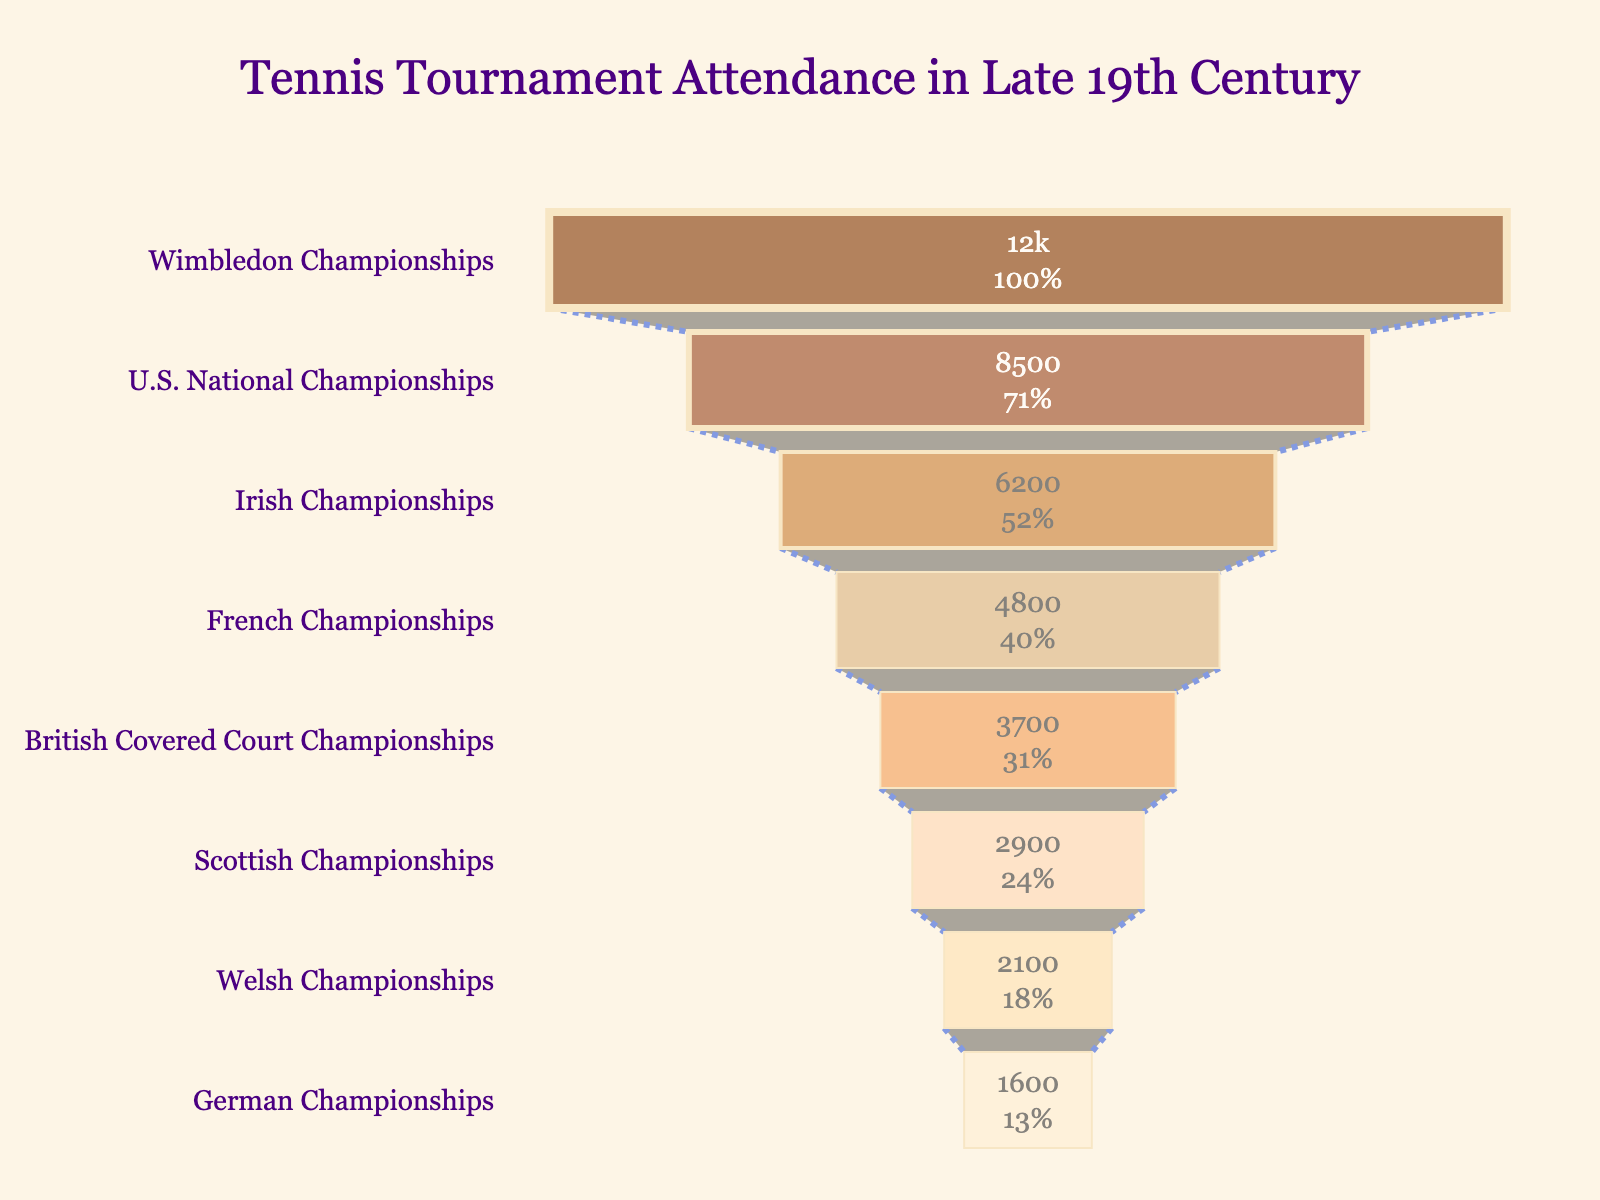What's the title of the chart? The title of the chart is clearly displayed at the top. It reads "Tennis Tournament Attendance in Late 19th Century."
Answer: Tennis Tournament Attendance in Late 19th Century How many tournaments are displayed in the chart? The chart shows multiple data points, each representing a tournament. Counting them, we see there are eight tournaments in total.
Answer: Eight Which tournament had the highest attendance? The highest value on the funnel chart corresponds to the top segment. The tournament at this level is the "Wimbledon Championships" with 12,000 attendance.
Answer: Wimbledon Championships What is the attendance figure for the U.S. National Championships? The funnel chart lists attendance figures alongside tournament names. The U.S. National Championships has an attendance of 8,500.
Answer: 8,500 Compare the attendance of the French Championships to the German Championships. The attendance figure for the French Championships is 4,800, while for the German Championships it is 1,600. The French Championships has a higher attendance.
Answer: French Championships has higher attendance What is the difference in attendance between the Wimbledon Championships and the lowest-attended tournament? The Wimbledon Championships has an attendance of 12,000, while the German Championships has the lowest attendance at 1,600. The difference is 12,000 - 1,600 = 10,400.
Answer: 10,400 What is the average attendance figure for the tournaments shown? Sum all attendance figures (12,000 + 8,500 + 6,200 + 4,800 + 3,700 + 2,900 + 2,100 + 1,600) = 41,800. Divide by the number of tournaments, which is 8. The average is 41,800 / 8 = 5,225.
Answer: 5,225 What percentage of the initial (Wimbledon Championships) attendance does the French Championships represent? The French Championships attendance is 4,800. The initial attendance (Wimbledon Championships) is 12,000. The percentage is (4,800 / 12,000) * 100% = 40%.
Answer: 40% How does the attendance of the Scottish Championships compare to the Irish Championships? The Scottish Championships have an attendance of 2,900, while the Irish Championships have 6,200. The Irish Championships have a higher attendance.
Answer: Irish Championships have higher attendance What color represents the French Championships in the funnel chart? Identifying the color in the chart, the French Championships is associated with a specific shade of brown in the sequence. It appears as the fourth shade in the color scale applied to the chart.
Answer: Light brown 